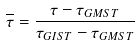<formula> <loc_0><loc_0><loc_500><loc_500>\overline { \tau } = \frac { \tau - \tau _ { G M S T } } { \tau _ { G I S T } - \tau _ { G M S T } }</formula> 